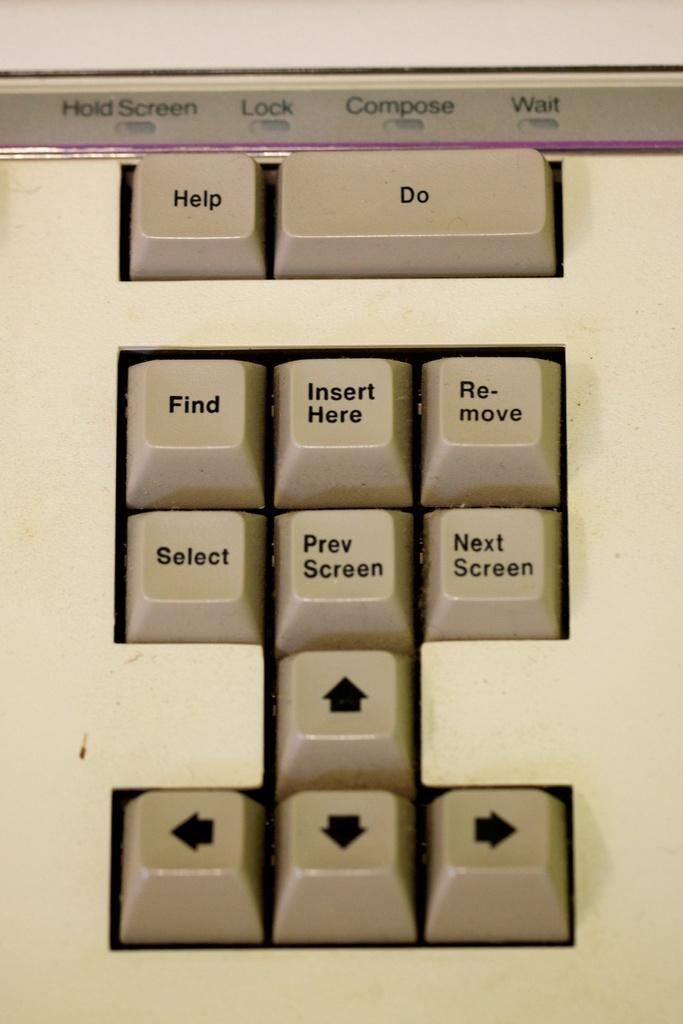<image>
Relay a brief, clear account of the picture shown. Several buttons on a keyboard are shown including the help button. 